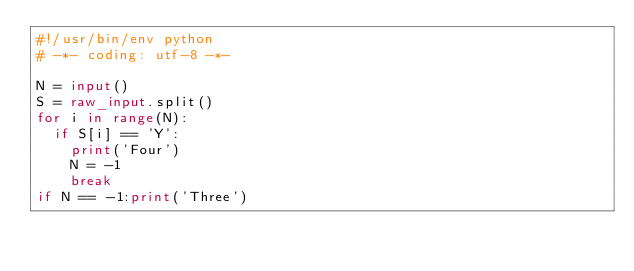Convert code to text. <code><loc_0><loc_0><loc_500><loc_500><_Python_>#!/usr/bin/env python
# -*- coding: utf-8 -*-

N = input()
S = raw_input.split()
for i in range(N):
	if S[i] == 'Y':
		print('Four')
		N = -1
		break
if N == -1:print('Three')</code> 